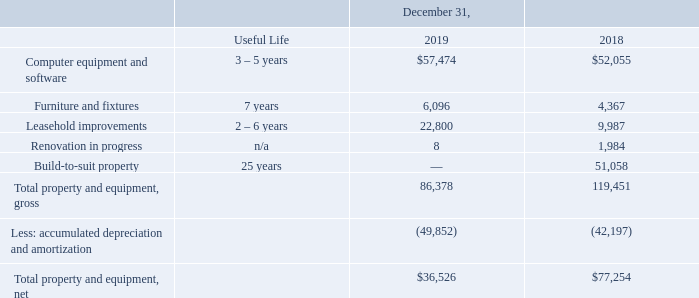7. OTHER BALANCE SHEET AMOUNTS
The components of property and equipment, net is as follows (in thousands):
Depreciation expense for the years ended December 31, 2019, 2018, and 2017 was $11.8 million, $10.2 million, and $10.3 million, respectively.
What was the depreciation expenses for 2018? $10.2 million. What was the depreciation expense for 2017? $10.3 million. What is the useful life of furniture and fixtures? 7 years. What is the change in computer equipment and software between 2018 and 2019?
Answer scale should be: thousand. ($57,474-$52,055)
Answer: 5419. What is the change in furniture and fixtures between 2018 and 2019?
Answer scale should be: thousand. (6,096-4,367)
Answer: 1729. What percentage of total property and equipment, gross consist of leasehold improvements in 2018?
Answer scale should be: percent. (9,987/119,451)
Answer: 8.36. 